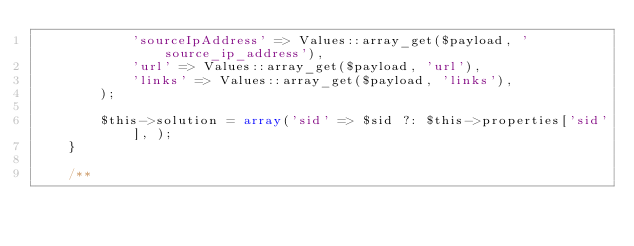Convert code to text. <code><loc_0><loc_0><loc_500><loc_500><_PHP_>            'sourceIpAddress' => Values::array_get($payload, 'source_ip_address'),
            'url' => Values::array_get($payload, 'url'),
            'links' => Values::array_get($payload, 'links'),
        );

        $this->solution = array('sid' => $sid ?: $this->properties['sid'], );
    }

    /**</code> 